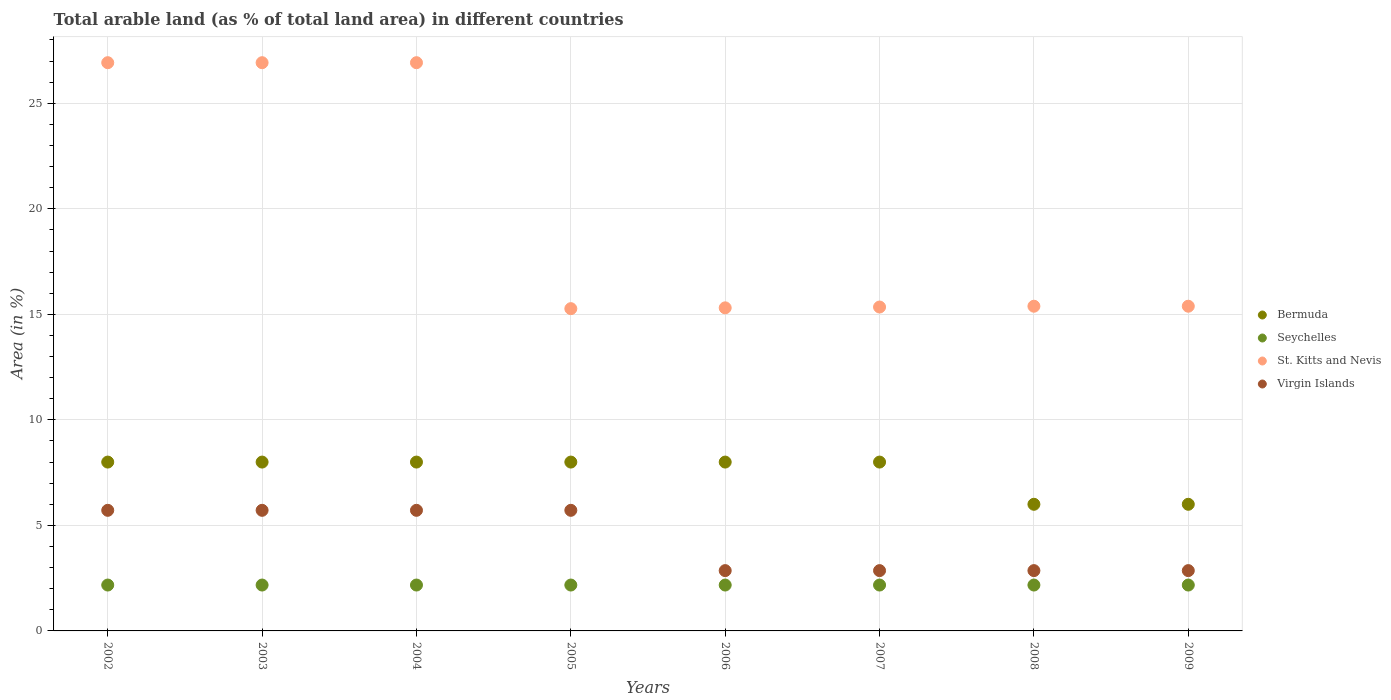How many different coloured dotlines are there?
Your answer should be compact. 4. What is the percentage of arable land in Virgin Islands in 2009?
Your response must be concise. 2.86. Across all years, what is the maximum percentage of arable land in Virgin Islands?
Ensure brevity in your answer.  5.71. Across all years, what is the minimum percentage of arable land in Bermuda?
Offer a terse response. 6. In which year was the percentage of arable land in Virgin Islands minimum?
Offer a terse response. 2006. What is the total percentage of arable land in St. Kitts and Nevis in the graph?
Make the answer very short. 157.46. What is the difference between the percentage of arable land in St. Kitts and Nevis in 2006 and that in 2008?
Make the answer very short. -0.08. What is the difference between the percentage of arable land in Virgin Islands in 2002 and the percentage of arable land in Seychelles in 2009?
Offer a terse response. 3.54. What is the average percentage of arable land in Seychelles per year?
Make the answer very short. 2.17. In the year 2009, what is the difference between the percentage of arable land in Virgin Islands and percentage of arable land in St. Kitts and Nevis?
Ensure brevity in your answer.  -12.53. In how many years, is the percentage of arable land in St. Kitts and Nevis greater than 27 %?
Provide a succinct answer. 0. Is the percentage of arable land in Virgin Islands in 2003 less than that in 2007?
Provide a succinct answer. No. Is the difference between the percentage of arable land in Virgin Islands in 2004 and 2006 greater than the difference between the percentage of arable land in St. Kitts and Nevis in 2004 and 2006?
Your response must be concise. No. What is the difference between the highest and the second highest percentage of arable land in Virgin Islands?
Provide a short and direct response. 0. What is the difference between the highest and the lowest percentage of arable land in St. Kitts and Nevis?
Provide a short and direct response. 11.65. Is it the case that in every year, the sum of the percentage of arable land in Virgin Islands and percentage of arable land in St. Kitts and Nevis  is greater than the percentage of arable land in Bermuda?
Provide a succinct answer. Yes. Is the percentage of arable land in Virgin Islands strictly greater than the percentage of arable land in Bermuda over the years?
Offer a very short reply. No. Is the percentage of arable land in Seychelles strictly less than the percentage of arable land in St. Kitts and Nevis over the years?
Give a very brief answer. Yes. How many dotlines are there?
Your response must be concise. 4. What is the difference between two consecutive major ticks on the Y-axis?
Keep it short and to the point. 5. Are the values on the major ticks of Y-axis written in scientific E-notation?
Offer a terse response. No. Does the graph contain any zero values?
Make the answer very short. No. Does the graph contain grids?
Your response must be concise. Yes. How many legend labels are there?
Your answer should be compact. 4. What is the title of the graph?
Your answer should be compact. Total arable land (as % of total land area) in different countries. Does "Switzerland" appear as one of the legend labels in the graph?
Your answer should be very brief. No. What is the label or title of the X-axis?
Offer a very short reply. Years. What is the label or title of the Y-axis?
Provide a succinct answer. Area (in %). What is the Area (in %) in Seychelles in 2002?
Provide a succinct answer. 2.17. What is the Area (in %) of St. Kitts and Nevis in 2002?
Offer a very short reply. 26.92. What is the Area (in %) of Virgin Islands in 2002?
Keep it short and to the point. 5.71. What is the Area (in %) of Bermuda in 2003?
Provide a succinct answer. 8. What is the Area (in %) in Seychelles in 2003?
Your answer should be very brief. 2.17. What is the Area (in %) in St. Kitts and Nevis in 2003?
Your response must be concise. 26.92. What is the Area (in %) in Virgin Islands in 2003?
Give a very brief answer. 5.71. What is the Area (in %) in Bermuda in 2004?
Offer a terse response. 8. What is the Area (in %) of Seychelles in 2004?
Give a very brief answer. 2.17. What is the Area (in %) in St. Kitts and Nevis in 2004?
Your answer should be very brief. 26.92. What is the Area (in %) of Virgin Islands in 2004?
Your answer should be very brief. 5.71. What is the Area (in %) of Seychelles in 2005?
Your answer should be very brief. 2.17. What is the Area (in %) of St. Kitts and Nevis in 2005?
Your response must be concise. 15.27. What is the Area (in %) of Virgin Islands in 2005?
Ensure brevity in your answer.  5.71. What is the Area (in %) in Bermuda in 2006?
Your answer should be compact. 8. What is the Area (in %) of Seychelles in 2006?
Offer a terse response. 2.17. What is the Area (in %) in St. Kitts and Nevis in 2006?
Your answer should be very brief. 15.31. What is the Area (in %) of Virgin Islands in 2006?
Provide a short and direct response. 2.86. What is the Area (in %) in Bermuda in 2007?
Provide a succinct answer. 8. What is the Area (in %) of Seychelles in 2007?
Your answer should be very brief. 2.17. What is the Area (in %) in St. Kitts and Nevis in 2007?
Offer a terse response. 15.35. What is the Area (in %) in Virgin Islands in 2007?
Keep it short and to the point. 2.86. What is the Area (in %) in Bermuda in 2008?
Your response must be concise. 6. What is the Area (in %) of Seychelles in 2008?
Your answer should be very brief. 2.17. What is the Area (in %) of St. Kitts and Nevis in 2008?
Your answer should be compact. 15.38. What is the Area (in %) in Virgin Islands in 2008?
Your answer should be very brief. 2.86. What is the Area (in %) in Seychelles in 2009?
Offer a terse response. 2.17. What is the Area (in %) of St. Kitts and Nevis in 2009?
Keep it short and to the point. 15.38. What is the Area (in %) of Virgin Islands in 2009?
Provide a short and direct response. 2.86. Across all years, what is the maximum Area (in %) in Seychelles?
Your answer should be compact. 2.17. Across all years, what is the maximum Area (in %) in St. Kitts and Nevis?
Your answer should be very brief. 26.92. Across all years, what is the maximum Area (in %) in Virgin Islands?
Make the answer very short. 5.71. Across all years, what is the minimum Area (in %) of Seychelles?
Give a very brief answer. 2.17. Across all years, what is the minimum Area (in %) of St. Kitts and Nevis?
Provide a short and direct response. 15.27. Across all years, what is the minimum Area (in %) of Virgin Islands?
Ensure brevity in your answer.  2.86. What is the total Area (in %) in Seychelles in the graph?
Keep it short and to the point. 17.39. What is the total Area (in %) of St. Kitts and Nevis in the graph?
Make the answer very short. 157.46. What is the total Area (in %) in Virgin Islands in the graph?
Give a very brief answer. 34.29. What is the difference between the Area (in %) of St. Kitts and Nevis in 2002 and that in 2003?
Keep it short and to the point. 0. What is the difference between the Area (in %) of Virgin Islands in 2002 and that in 2003?
Offer a very short reply. 0. What is the difference between the Area (in %) of Seychelles in 2002 and that in 2004?
Offer a very short reply. 0. What is the difference between the Area (in %) in St. Kitts and Nevis in 2002 and that in 2004?
Offer a very short reply. 0. What is the difference between the Area (in %) in Virgin Islands in 2002 and that in 2004?
Provide a succinct answer. 0. What is the difference between the Area (in %) in Bermuda in 2002 and that in 2005?
Make the answer very short. 0. What is the difference between the Area (in %) in Seychelles in 2002 and that in 2005?
Ensure brevity in your answer.  0. What is the difference between the Area (in %) of St. Kitts and Nevis in 2002 and that in 2005?
Offer a very short reply. 11.65. What is the difference between the Area (in %) in Seychelles in 2002 and that in 2006?
Your response must be concise. 0. What is the difference between the Area (in %) in St. Kitts and Nevis in 2002 and that in 2006?
Give a very brief answer. 11.62. What is the difference between the Area (in %) of Virgin Islands in 2002 and that in 2006?
Provide a short and direct response. 2.86. What is the difference between the Area (in %) of Bermuda in 2002 and that in 2007?
Your answer should be compact. 0. What is the difference between the Area (in %) of Seychelles in 2002 and that in 2007?
Provide a succinct answer. 0. What is the difference between the Area (in %) of St. Kitts and Nevis in 2002 and that in 2007?
Make the answer very short. 11.58. What is the difference between the Area (in %) of Virgin Islands in 2002 and that in 2007?
Ensure brevity in your answer.  2.86. What is the difference between the Area (in %) in Bermuda in 2002 and that in 2008?
Make the answer very short. 2. What is the difference between the Area (in %) of Seychelles in 2002 and that in 2008?
Make the answer very short. 0. What is the difference between the Area (in %) in St. Kitts and Nevis in 2002 and that in 2008?
Your response must be concise. 11.54. What is the difference between the Area (in %) of Virgin Islands in 2002 and that in 2008?
Provide a succinct answer. 2.86. What is the difference between the Area (in %) of Seychelles in 2002 and that in 2009?
Keep it short and to the point. 0. What is the difference between the Area (in %) of St. Kitts and Nevis in 2002 and that in 2009?
Offer a very short reply. 11.54. What is the difference between the Area (in %) in Virgin Islands in 2002 and that in 2009?
Provide a short and direct response. 2.86. What is the difference between the Area (in %) of Bermuda in 2003 and that in 2004?
Offer a very short reply. 0. What is the difference between the Area (in %) in Seychelles in 2003 and that in 2004?
Keep it short and to the point. 0. What is the difference between the Area (in %) of Bermuda in 2003 and that in 2005?
Offer a very short reply. 0. What is the difference between the Area (in %) of St. Kitts and Nevis in 2003 and that in 2005?
Keep it short and to the point. 11.65. What is the difference between the Area (in %) of Virgin Islands in 2003 and that in 2005?
Provide a short and direct response. 0. What is the difference between the Area (in %) of Bermuda in 2003 and that in 2006?
Offer a terse response. 0. What is the difference between the Area (in %) of Seychelles in 2003 and that in 2006?
Offer a terse response. 0. What is the difference between the Area (in %) in St. Kitts and Nevis in 2003 and that in 2006?
Your answer should be compact. 11.62. What is the difference between the Area (in %) of Virgin Islands in 2003 and that in 2006?
Offer a terse response. 2.86. What is the difference between the Area (in %) in Bermuda in 2003 and that in 2007?
Provide a short and direct response. 0. What is the difference between the Area (in %) in Seychelles in 2003 and that in 2007?
Offer a terse response. 0. What is the difference between the Area (in %) in St. Kitts and Nevis in 2003 and that in 2007?
Offer a very short reply. 11.58. What is the difference between the Area (in %) in Virgin Islands in 2003 and that in 2007?
Your answer should be very brief. 2.86. What is the difference between the Area (in %) in St. Kitts and Nevis in 2003 and that in 2008?
Provide a succinct answer. 11.54. What is the difference between the Area (in %) of Virgin Islands in 2003 and that in 2008?
Make the answer very short. 2.86. What is the difference between the Area (in %) of Seychelles in 2003 and that in 2009?
Make the answer very short. 0. What is the difference between the Area (in %) of St. Kitts and Nevis in 2003 and that in 2009?
Your answer should be compact. 11.54. What is the difference between the Area (in %) of Virgin Islands in 2003 and that in 2009?
Provide a succinct answer. 2.86. What is the difference between the Area (in %) of St. Kitts and Nevis in 2004 and that in 2005?
Keep it short and to the point. 11.65. What is the difference between the Area (in %) of Virgin Islands in 2004 and that in 2005?
Your answer should be very brief. 0. What is the difference between the Area (in %) in St. Kitts and Nevis in 2004 and that in 2006?
Your answer should be compact. 11.62. What is the difference between the Area (in %) of Virgin Islands in 2004 and that in 2006?
Ensure brevity in your answer.  2.86. What is the difference between the Area (in %) in Bermuda in 2004 and that in 2007?
Your answer should be compact. 0. What is the difference between the Area (in %) of Seychelles in 2004 and that in 2007?
Your response must be concise. 0. What is the difference between the Area (in %) of St. Kitts and Nevis in 2004 and that in 2007?
Provide a succinct answer. 11.58. What is the difference between the Area (in %) in Virgin Islands in 2004 and that in 2007?
Provide a short and direct response. 2.86. What is the difference between the Area (in %) of St. Kitts and Nevis in 2004 and that in 2008?
Offer a very short reply. 11.54. What is the difference between the Area (in %) in Virgin Islands in 2004 and that in 2008?
Offer a very short reply. 2.86. What is the difference between the Area (in %) of Seychelles in 2004 and that in 2009?
Your answer should be very brief. 0. What is the difference between the Area (in %) of St. Kitts and Nevis in 2004 and that in 2009?
Your answer should be compact. 11.54. What is the difference between the Area (in %) of Virgin Islands in 2004 and that in 2009?
Keep it short and to the point. 2.86. What is the difference between the Area (in %) of Seychelles in 2005 and that in 2006?
Make the answer very short. 0. What is the difference between the Area (in %) in St. Kitts and Nevis in 2005 and that in 2006?
Keep it short and to the point. -0.04. What is the difference between the Area (in %) in Virgin Islands in 2005 and that in 2006?
Keep it short and to the point. 2.86. What is the difference between the Area (in %) in Seychelles in 2005 and that in 2007?
Keep it short and to the point. 0. What is the difference between the Area (in %) in St. Kitts and Nevis in 2005 and that in 2007?
Provide a short and direct response. -0.08. What is the difference between the Area (in %) in Virgin Islands in 2005 and that in 2007?
Ensure brevity in your answer.  2.86. What is the difference between the Area (in %) in Bermuda in 2005 and that in 2008?
Your response must be concise. 2. What is the difference between the Area (in %) of St. Kitts and Nevis in 2005 and that in 2008?
Provide a succinct answer. -0.12. What is the difference between the Area (in %) of Virgin Islands in 2005 and that in 2008?
Offer a very short reply. 2.86. What is the difference between the Area (in %) in Seychelles in 2005 and that in 2009?
Ensure brevity in your answer.  0. What is the difference between the Area (in %) in St. Kitts and Nevis in 2005 and that in 2009?
Ensure brevity in your answer.  -0.12. What is the difference between the Area (in %) of Virgin Islands in 2005 and that in 2009?
Your answer should be very brief. 2.86. What is the difference between the Area (in %) in Seychelles in 2006 and that in 2007?
Offer a terse response. 0. What is the difference between the Area (in %) in St. Kitts and Nevis in 2006 and that in 2007?
Provide a succinct answer. -0.04. What is the difference between the Area (in %) of Virgin Islands in 2006 and that in 2007?
Your response must be concise. 0. What is the difference between the Area (in %) of Seychelles in 2006 and that in 2008?
Provide a succinct answer. 0. What is the difference between the Area (in %) in St. Kitts and Nevis in 2006 and that in 2008?
Provide a succinct answer. -0.08. What is the difference between the Area (in %) in Virgin Islands in 2006 and that in 2008?
Keep it short and to the point. 0. What is the difference between the Area (in %) in Seychelles in 2006 and that in 2009?
Provide a succinct answer. 0. What is the difference between the Area (in %) in St. Kitts and Nevis in 2006 and that in 2009?
Give a very brief answer. -0.08. What is the difference between the Area (in %) of Virgin Islands in 2006 and that in 2009?
Offer a very short reply. 0. What is the difference between the Area (in %) in Seychelles in 2007 and that in 2008?
Keep it short and to the point. 0. What is the difference between the Area (in %) of St. Kitts and Nevis in 2007 and that in 2008?
Ensure brevity in your answer.  -0.04. What is the difference between the Area (in %) of St. Kitts and Nevis in 2007 and that in 2009?
Provide a succinct answer. -0.04. What is the difference between the Area (in %) in Bermuda in 2008 and that in 2009?
Ensure brevity in your answer.  0. What is the difference between the Area (in %) of Seychelles in 2008 and that in 2009?
Offer a very short reply. 0. What is the difference between the Area (in %) of Bermuda in 2002 and the Area (in %) of Seychelles in 2003?
Offer a terse response. 5.83. What is the difference between the Area (in %) in Bermuda in 2002 and the Area (in %) in St. Kitts and Nevis in 2003?
Your answer should be very brief. -18.92. What is the difference between the Area (in %) of Bermuda in 2002 and the Area (in %) of Virgin Islands in 2003?
Provide a short and direct response. 2.29. What is the difference between the Area (in %) of Seychelles in 2002 and the Area (in %) of St. Kitts and Nevis in 2003?
Make the answer very short. -24.75. What is the difference between the Area (in %) of Seychelles in 2002 and the Area (in %) of Virgin Islands in 2003?
Make the answer very short. -3.54. What is the difference between the Area (in %) of St. Kitts and Nevis in 2002 and the Area (in %) of Virgin Islands in 2003?
Provide a succinct answer. 21.21. What is the difference between the Area (in %) in Bermuda in 2002 and the Area (in %) in Seychelles in 2004?
Keep it short and to the point. 5.83. What is the difference between the Area (in %) of Bermuda in 2002 and the Area (in %) of St. Kitts and Nevis in 2004?
Keep it short and to the point. -18.92. What is the difference between the Area (in %) of Bermuda in 2002 and the Area (in %) of Virgin Islands in 2004?
Keep it short and to the point. 2.29. What is the difference between the Area (in %) in Seychelles in 2002 and the Area (in %) in St. Kitts and Nevis in 2004?
Give a very brief answer. -24.75. What is the difference between the Area (in %) of Seychelles in 2002 and the Area (in %) of Virgin Islands in 2004?
Keep it short and to the point. -3.54. What is the difference between the Area (in %) in St. Kitts and Nevis in 2002 and the Area (in %) in Virgin Islands in 2004?
Ensure brevity in your answer.  21.21. What is the difference between the Area (in %) in Bermuda in 2002 and the Area (in %) in Seychelles in 2005?
Your answer should be compact. 5.83. What is the difference between the Area (in %) of Bermuda in 2002 and the Area (in %) of St. Kitts and Nevis in 2005?
Offer a very short reply. -7.27. What is the difference between the Area (in %) in Bermuda in 2002 and the Area (in %) in Virgin Islands in 2005?
Give a very brief answer. 2.29. What is the difference between the Area (in %) of Seychelles in 2002 and the Area (in %) of St. Kitts and Nevis in 2005?
Your answer should be compact. -13.1. What is the difference between the Area (in %) of Seychelles in 2002 and the Area (in %) of Virgin Islands in 2005?
Provide a short and direct response. -3.54. What is the difference between the Area (in %) of St. Kitts and Nevis in 2002 and the Area (in %) of Virgin Islands in 2005?
Provide a succinct answer. 21.21. What is the difference between the Area (in %) of Bermuda in 2002 and the Area (in %) of Seychelles in 2006?
Ensure brevity in your answer.  5.83. What is the difference between the Area (in %) in Bermuda in 2002 and the Area (in %) in St. Kitts and Nevis in 2006?
Your response must be concise. -7.31. What is the difference between the Area (in %) in Bermuda in 2002 and the Area (in %) in Virgin Islands in 2006?
Your response must be concise. 5.14. What is the difference between the Area (in %) in Seychelles in 2002 and the Area (in %) in St. Kitts and Nevis in 2006?
Provide a succinct answer. -13.13. What is the difference between the Area (in %) in Seychelles in 2002 and the Area (in %) in Virgin Islands in 2006?
Provide a succinct answer. -0.68. What is the difference between the Area (in %) of St. Kitts and Nevis in 2002 and the Area (in %) of Virgin Islands in 2006?
Provide a succinct answer. 24.07. What is the difference between the Area (in %) in Bermuda in 2002 and the Area (in %) in Seychelles in 2007?
Your answer should be very brief. 5.83. What is the difference between the Area (in %) in Bermuda in 2002 and the Area (in %) in St. Kitts and Nevis in 2007?
Provide a short and direct response. -7.35. What is the difference between the Area (in %) in Bermuda in 2002 and the Area (in %) in Virgin Islands in 2007?
Offer a terse response. 5.14. What is the difference between the Area (in %) of Seychelles in 2002 and the Area (in %) of St. Kitts and Nevis in 2007?
Your answer should be very brief. -13.17. What is the difference between the Area (in %) of Seychelles in 2002 and the Area (in %) of Virgin Islands in 2007?
Provide a short and direct response. -0.68. What is the difference between the Area (in %) of St. Kitts and Nevis in 2002 and the Area (in %) of Virgin Islands in 2007?
Make the answer very short. 24.07. What is the difference between the Area (in %) of Bermuda in 2002 and the Area (in %) of Seychelles in 2008?
Provide a short and direct response. 5.83. What is the difference between the Area (in %) in Bermuda in 2002 and the Area (in %) in St. Kitts and Nevis in 2008?
Keep it short and to the point. -7.38. What is the difference between the Area (in %) of Bermuda in 2002 and the Area (in %) of Virgin Islands in 2008?
Provide a succinct answer. 5.14. What is the difference between the Area (in %) in Seychelles in 2002 and the Area (in %) in St. Kitts and Nevis in 2008?
Your response must be concise. -13.21. What is the difference between the Area (in %) in Seychelles in 2002 and the Area (in %) in Virgin Islands in 2008?
Provide a short and direct response. -0.68. What is the difference between the Area (in %) of St. Kitts and Nevis in 2002 and the Area (in %) of Virgin Islands in 2008?
Make the answer very short. 24.07. What is the difference between the Area (in %) in Bermuda in 2002 and the Area (in %) in Seychelles in 2009?
Make the answer very short. 5.83. What is the difference between the Area (in %) of Bermuda in 2002 and the Area (in %) of St. Kitts and Nevis in 2009?
Make the answer very short. -7.38. What is the difference between the Area (in %) of Bermuda in 2002 and the Area (in %) of Virgin Islands in 2009?
Ensure brevity in your answer.  5.14. What is the difference between the Area (in %) of Seychelles in 2002 and the Area (in %) of St. Kitts and Nevis in 2009?
Keep it short and to the point. -13.21. What is the difference between the Area (in %) in Seychelles in 2002 and the Area (in %) in Virgin Islands in 2009?
Your answer should be very brief. -0.68. What is the difference between the Area (in %) of St. Kitts and Nevis in 2002 and the Area (in %) of Virgin Islands in 2009?
Keep it short and to the point. 24.07. What is the difference between the Area (in %) in Bermuda in 2003 and the Area (in %) in Seychelles in 2004?
Keep it short and to the point. 5.83. What is the difference between the Area (in %) of Bermuda in 2003 and the Area (in %) of St. Kitts and Nevis in 2004?
Your response must be concise. -18.92. What is the difference between the Area (in %) in Bermuda in 2003 and the Area (in %) in Virgin Islands in 2004?
Give a very brief answer. 2.29. What is the difference between the Area (in %) in Seychelles in 2003 and the Area (in %) in St. Kitts and Nevis in 2004?
Provide a succinct answer. -24.75. What is the difference between the Area (in %) in Seychelles in 2003 and the Area (in %) in Virgin Islands in 2004?
Give a very brief answer. -3.54. What is the difference between the Area (in %) in St. Kitts and Nevis in 2003 and the Area (in %) in Virgin Islands in 2004?
Provide a short and direct response. 21.21. What is the difference between the Area (in %) of Bermuda in 2003 and the Area (in %) of Seychelles in 2005?
Provide a short and direct response. 5.83. What is the difference between the Area (in %) in Bermuda in 2003 and the Area (in %) in St. Kitts and Nevis in 2005?
Ensure brevity in your answer.  -7.27. What is the difference between the Area (in %) in Bermuda in 2003 and the Area (in %) in Virgin Islands in 2005?
Keep it short and to the point. 2.29. What is the difference between the Area (in %) in Seychelles in 2003 and the Area (in %) in St. Kitts and Nevis in 2005?
Keep it short and to the point. -13.1. What is the difference between the Area (in %) of Seychelles in 2003 and the Area (in %) of Virgin Islands in 2005?
Keep it short and to the point. -3.54. What is the difference between the Area (in %) in St. Kitts and Nevis in 2003 and the Area (in %) in Virgin Islands in 2005?
Offer a very short reply. 21.21. What is the difference between the Area (in %) of Bermuda in 2003 and the Area (in %) of Seychelles in 2006?
Your answer should be very brief. 5.83. What is the difference between the Area (in %) in Bermuda in 2003 and the Area (in %) in St. Kitts and Nevis in 2006?
Provide a short and direct response. -7.31. What is the difference between the Area (in %) in Bermuda in 2003 and the Area (in %) in Virgin Islands in 2006?
Ensure brevity in your answer.  5.14. What is the difference between the Area (in %) of Seychelles in 2003 and the Area (in %) of St. Kitts and Nevis in 2006?
Give a very brief answer. -13.13. What is the difference between the Area (in %) in Seychelles in 2003 and the Area (in %) in Virgin Islands in 2006?
Provide a succinct answer. -0.68. What is the difference between the Area (in %) in St. Kitts and Nevis in 2003 and the Area (in %) in Virgin Islands in 2006?
Offer a very short reply. 24.07. What is the difference between the Area (in %) in Bermuda in 2003 and the Area (in %) in Seychelles in 2007?
Your answer should be very brief. 5.83. What is the difference between the Area (in %) of Bermuda in 2003 and the Area (in %) of St. Kitts and Nevis in 2007?
Offer a terse response. -7.35. What is the difference between the Area (in %) in Bermuda in 2003 and the Area (in %) in Virgin Islands in 2007?
Give a very brief answer. 5.14. What is the difference between the Area (in %) in Seychelles in 2003 and the Area (in %) in St. Kitts and Nevis in 2007?
Offer a very short reply. -13.17. What is the difference between the Area (in %) of Seychelles in 2003 and the Area (in %) of Virgin Islands in 2007?
Provide a short and direct response. -0.68. What is the difference between the Area (in %) of St. Kitts and Nevis in 2003 and the Area (in %) of Virgin Islands in 2007?
Offer a very short reply. 24.07. What is the difference between the Area (in %) in Bermuda in 2003 and the Area (in %) in Seychelles in 2008?
Your answer should be very brief. 5.83. What is the difference between the Area (in %) in Bermuda in 2003 and the Area (in %) in St. Kitts and Nevis in 2008?
Make the answer very short. -7.38. What is the difference between the Area (in %) in Bermuda in 2003 and the Area (in %) in Virgin Islands in 2008?
Keep it short and to the point. 5.14. What is the difference between the Area (in %) of Seychelles in 2003 and the Area (in %) of St. Kitts and Nevis in 2008?
Make the answer very short. -13.21. What is the difference between the Area (in %) in Seychelles in 2003 and the Area (in %) in Virgin Islands in 2008?
Provide a short and direct response. -0.68. What is the difference between the Area (in %) in St. Kitts and Nevis in 2003 and the Area (in %) in Virgin Islands in 2008?
Provide a short and direct response. 24.07. What is the difference between the Area (in %) of Bermuda in 2003 and the Area (in %) of Seychelles in 2009?
Provide a succinct answer. 5.83. What is the difference between the Area (in %) in Bermuda in 2003 and the Area (in %) in St. Kitts and Nevis in 2009?
Provide a short and direct response. -7.38. What is the difference between the Area (in %) of Bermuda in 2003 and the Area (in %) of Virgin Islands in 2009?
Provide a succinct answer. 5.14. What is the difference between the Area (in %) in Seychelles in 2003 and the Area (in %) in St. Kitts and Nevis in 2009?
Keep it short and to the point. -13.21. What is the difference between the Area (in %) of Seychelles in 2003 and the Area (in %) of Virgin Islands in 2009?
Provide a short and direct response. -0.68. What is the difference between the Area (in %) in St. Kitts and Nevis in 2003 and the Area (in %) in Virgin Islands in 2009?
Make the answer very short. 24.07. What is the difference between the Area (in %) in Bermuda in 2004 and the Area (in %) in Seychelles in 2005?
Your response must be concise. 5.83. What is the difference between the Area (in %) in Bermuda in 2004 and the Area (in %) in St. Kitts and Nevis in 2005?
Give a very brief answer. -7.27. What is the difference between the Area (in %) in Bermuda in 2004 and the Area (in %) in Virgin Islands in 2005?
Offer a terse response. 2.29. What is the difference between the Area (in %) in Seychelles in 2004 and the Area (in %) in St. Kitts and Nevis in 2005?
Make the answer very short. -13.1. What is the difference between the Area (in %) in Seychelles in 2004 and the Area (in %) in Virgin Islands in 2005?
Your answer should be very brief. -3.54. What is the difference between the Area (in %) in St. Kitts and Nevis in 2004 and the Area (in %) in Virgin Islands in 2005?
Provide a short and direct response. 21.21. What is the difference between the Area (in %) of Bermuda in 2004 and the Area (in %) of Seychelles in 2006?
Offer a very short reply. 5.83. What is the difference between the Area (in %) in Bermuda in 2004 and the Area (in %) in St. Kitts and Nevis in 2006?
Give a very brief answer. -7.31. What is the difference between the Area (in %) of Bermuda in 2004 and the Area (in %) of Virgin Islands in 2006?
Your response must be concise. 5.14. What is the difference between the Area (in %) of Seychelles in 2004 and the Area (in %) of St. Kitts and Nevis in 2006?
Provide a succinct answer. -13.13. What is the difference between the Area (in %) in Seychelles in 2004 and the Area (in %) in Virgin Islands in 2006?
Offer a very short reply. -0.68. What is the difference between the Area (in %) in St. Kitts and Nevis in 2004 and the Area (in %) in Virgin Islands in 2006?
Your response must be concise. 24.07. What is the difference between the Area (in %) in Bermuda in 2004 and the Area (in %) in Seychelles in 2007?
Provide a short and direct response. 5.83. What is the difference between the Area (in %) of Bermuda in 2004 and the Area (in %) of St. Kitts and Nevis in 2007?
Your answer should be very brief. -7.35. What is the difference between the Area (in %) in Bermuda in 2004 and the Area (in %) in Virgin Islands in 2007?
Your answer should be very brief. 5.14. What is the difference between the Area (in %) of Seychelles in 2004 and the Area (in %) of St. Kitts and Nevis in 2007?
Offer a very short reply. -13.17. What is the difference between the Area (in %) in Seychelles in 2004 and the Area (in %) in Virgin Islands in 2007?
Make the answer very short. -0.68. What is the difference between the Area (in %) of St. Kitts and Nevis in 2004 and the Area (in %) of Virgin Islands in 2007?
Provide a short and direct response. 24.07. What is the difference between the Area (in %) in Bermuda in 2004 and the Area (in %) in Seychelles in 2008?
Make the answer very short. 5.83. What is the difference between the Area (in %) in Bermuda in 2004 and the Area (in %) in St. Kitts and Nevis in 2008?
Provide a short and direct response. -7.38. What is the difference between the Area (in %) of Bermuda in 2004 and the Area (in %) of Virgin Islands in 2008?
Give a very brief answer. 5.14. What is the difference between the Area (in %) of Seychelles in 2004 and the Area (in %) of St. Kitts and Nevis in 2008?
Offer a very short reply. -13.21. What is the difference between the Area (in %) in Seychelles in 2004 and the Area (in %) in Virgin Islands in 2008?
Keep it short and to the point. -0.68. What is the difference between the Area (in %) of St. Kitts and Nevis in 2004 and the Area (in %) of Virgin Islands in 2008?
Provide a succinct answer. 24.07. What is the difference between the Area (in %) of Bermuda in 2004 and the Area (in %) of Seychelles in 2009?
Provide a short and direct response. 5.83. What is the difference between the Area (in %) of Bermuda in 2004 and the Area (in %) of St. Kitts and Nevis in 2009?
Your response must be concise. -7.38. What is the difference between the Area (in %) in Bermuda in 2004 and the Area (in %) in Virgin Islands in 2009?
Your answer should be compact. 5.14. What is the difference between the Area (in %) of Seychelles in 2004 and the Area (in %) of St. Kitts and Nevis in 2009?
Give a very brief answer. -13.21. What is the difference between the Area (in %) in Seychelles in 2004 and the Area (in %) in Virgin Islands in 2009?
Your response must be concise. -0.68. What is the difference between the Area (in %) in St. Kitts and Nevis in 2004 and the Area (in %) in Virgin Islands in 2009?
Offer a terse response. 24.07. What is the difference between the Area (in %) of Bermuda in 2005 and the Area (in %) of Seychelles in 2006?
Your answer should be very brief. 5.83. What is the difference between the Area (in %) of Bermuda in 2005 and the Area (in %) of St. Kitts and Nevis in 2006?
Your response must be concise. -7.31. What is the difference between the Area (in %) in Bermuda in 2005 and the Area (in %) in Virgin Islands in 2006?
Make the answer very short. 5.14. What is the difference between the Area (in %) in Seychelles in 2005 and the Area (in %) in St. Kitts and Nevis in 2006?
Offer a terse response. -13.13. What is the difference between the Area (in %) of Seychelles in 2005 and the Area (in %) of Virgin Islands in 2006?
Your answer should be compact. -0.68. What is the difference between the Area (in %) in St. Kitts and Nevis in 2005 and the Area (in %) in Virgin Islands in 2006?
Ensure brevity in your answer.  12.41. What is the difference between the Area (in %) in Bermuda in 2005 and the Area (in %) in Seychelles in 2007?
Offer a very short reply. 5.83. What is the difference between the Area (in %) in Bermuda in 2005 and the Area (in %) in St. Kitts and Nevis in 2007?
Provide a succinct answer. -7.35. What is the difference between the Area (in %) in Bermuda in 2005 and the Area (in %) in Virgin Islands in 2007?
Provide a short and direct response. 5.14. What is the difference between the Area (in %) in Seychelles in 2005 and the Area (in %) in St. Kitts and Nevis in 2007?
Ensure brevity in your answer.  -13.17. What is the difference between the Area (in %) of Seychelles in 2005 and the Area (in %) of Virgin Islands in 2007?
Offer a very short reply. -0.68. What is the difference between the Area (in %) in St. Kitts and Nevis in 2005 and the Area (in %) in Virgin Islands in 2007?
Ensure brevity in your answer.  12.41. What is the difference between the Area (in %) of Bermuda in 2005 and the Area (in %) of Seychelles in 2008?
Provide a succinct answer. 5.83. What is the difference between the Area (in %) in Bermuda in 2005 and the Area (in %) in St. Kitts and Nevis in 2008?
Ensure brevity in your answer.  -7.38. What is the difference between the Area (in %) of Bermuda in 2005 and the Area (in %) of Virgin Islands in 2008?
Your answer should be very brief. 5.14. What is the difference between the Area (in %) in Seychelles in 2005 and the Area (in %) in St. Kitts and Nevis in 2008?
Provide a short and direct response. -13.21. What is the difference between the Area (in %) of Seychelles in 2005 and the Area (in %) of Virgin Islands in 2008?
Offer a terse response. -0.68. What is the difference between the Area (in %) in St. Kitts and Nevis in 2005 and the Area (in %) in Virgin Islands in 2008?
Make the answer very short. 12.41. What is the difference between the Area (in %) of Bermuda in 2005 and the Area (in %) of Seychelles in 2009?
Offer a very short reply. 5.83. What is the difference between the Area (in %) of Bermuda in 2005 and the Area (in %) of St. Kitts and Nevis in 2009?
Ensure brevity in your answer.  -7.38. What is the difference between the Area (in %) of Bermuda in 2005 and the Area (in %) of Virgin Islands in 2009?
Provide a succinct answer. 5.14. What is the difference between the Area (in %) in Seychelles in 2005 and the Area (in %) in St. Kitts and Nevis in 2009?
Your answer should be very brief. -13.21. What is the difference between the Area (in %) in Seychelles in 2005 and the Area (in %) in Virgin Islands in 2009?
Your answer should be very brief. -0.68. What is the difference between the Area (in %) in St. Kitts and Nevis in 2005 and the Area (in %) in Virgin Islands in 2009?
Your answer should be compact. 12.41. What is the difference between the Area (in %) of Bermuda in 2006 and the Area (in %) of Seychelles in 2007?
Provide a succinct answer. 5.83. What is the difference between the Area (in %) of Bermuda in 2006 and the Area (in %) of St. Kitts and Nevis in 2007?
Your answer should be compact. -7.35. What is the difference between the Area (in %) of Bermuda in 2006 and the Area (in %) of Virgin Islands in 2007?
Make the answer very short. 5.14. What is the difference between the Area (in %) in Seychelles in 2006 and the Area (in %) in St. Kitts and Nevis in 2007?
Ensure brevity in your answer.  -13.17. What is the difference between the Area (in %) of Seychelles in 2006 and the Area (in %) of Virgin Islands in 2007?
Give a very brief answer. -0.68. What is the difference between the Area (in %) in St. Kitts and Nevis in 2006 and the Area (in %) in Virgin Islands in 2007?
Give a very brief answer. 12.45. What is the difference between the Area (in %) in Bermuda in 2006 and the Area (in %) in Seychelles in 2008?
Offer a very short reply. 5.83. What is the difference between the Area (in %) in Bermuda in 2006 and the Area (in %) in St. Kitts and Nevis in 2008?
Keep it short and to the point. -7.38. What is the difference between the Area (in %) of Bermuda in 2006 and the Area (in %) of Virgin Islands in 2008?
Make the answer very short. 5.14. What is the difference between the Area (in %) of Seychelles in 2006 and the Area (in %) of St. Kitts and Nevis in 2008?
Your answer should be very brief. -13.21. What is the difference between the Area (in %) of Seychelles in 2006 and the Area (in %) of Virgin Islands in 2008?
Your answer should be compact. -0.68. What is the difference between the Area (in %) in St. Kitts and Nevis in 2006 and the Area (in %) in Virgin Islands in 2008?
Your answer should be compact. 12.45. What is the difference between the Area (in %) of Bermuda in 2006 and the Area (in %) of Seychelles in 2009?
Offer a very short reply. 5.83. What is the difference between the Area (in %) in Bermuda in 2006 and the Area (in %) in St. Kitts and Nevis in 2009?
Your answer should be compact. -7.38. What is the difference between the Area (in %) of Bermuda in 2006 and the Area (in %) of Virgin Islands in 2009?
Your answer should be very brief. 5.14. What is the difference between the Area (in %) in Seychelles in 2006 and the Area (in %) in St. Kitts and Nevis in 2009?
Provide a short and direct response. -13.21. What is the difference between the Area (in %) of Seychelles in 2006 and the Area (in %) of Virgin Islands in 2009?
Make the answer very short. -0.68. What is the difference between the Area (in %) of St. Kitts and Nevis in 2006 and the Area (in %) of Virgin Islands in 2009?
Give a very brief answer. 12.45. What is the difference between the Area (in %) in Bermuda in 2007 and the Area (in %) in Seychelles in 2008?
Make the answer very short. 5.83. What is the difference between the Area (in %) in Bermuda in 2007 and the Area (in %) in St. Kitts and Nevis in 2008?
Make the answer very short. -7.38. What is the difference between the Area (in %) of Bermuda in 2007 and the Area (in %) of Virgin Islands in 2008?
Give a very brief answer. 5.14. What is the difference between the Area (in %) of Seychelles in 2007 and the Area (in %) of St. Kitts and Nevis in 2008?
Your response must be concise. -13.21. What is the difference between the Area (in %) in Seychelles in 2007 and the Area (in %) in Virgin Islands in 2008?
Your response must be concise. -0.68. What is the difference between the Area (in %) of St. Kitts and Nevis in 2007 and the Area (in %) of Virgin Islands in 2008?
Give a very brief answer. 12.49. What is the difference between the Area (in %) in Bermuda in 2007 and the Area (in %) in Seychelles in 2009?
Keep it short and to the point. 5.83. What is the difference between the Area (in %) in Bermuda in 2007 and the Area (in %) in St. Kitts and Nevis in 2009?
Offer a very short reply. -7.38. What is the difference between the Area (in %) in Bermuda in 2007 and the Area (in %) in Virgin Islands in 2009?
Make the answer very short. 5.14. What is the difference between the Area (in %) in Seychelles in 2007 and the Area (in %) in St. Kitts and Nevis in 2009?
Ensure brevity in your answer.  -13.21. What is the difference between the Area (in %) in Seychelles in 2007 and the Area (in %) in Virgin Islands in 2009?
Ensure brevity in your answer.  -0.68. What is the difference between the Area (in %) in St. Kitts and Nevis in 2007 and the Area (in %) in Virgin Islands in 2009?
Your response must be concise. 12.49. What is the difference between the Area (in %) of Bermuda in 2008 and the Area (in %) of Seychelles in 2009?
Provide a short and direct response. 3.83. What is the difference between the Area (in %) of Bermuda in 2008 and the Area (in %) of St. Kitts and Nevis in 2009?
Offer a very short reply. -9.38. What is the difference between the Area (in %) of Bermuda in 2008 and the Area (in %) of Virgin Islands in 2009?
Give a very brief answer. 3.14. What is the difference between the Area (in %) of Seychelles in 2008 and the Area (in %) of St. Kitts and Nevis in 2009?
Ensure brevity in your answer.  -13.21. What is the difference between the Area (in %) of Seychelles in 2008 and the Area (in %) of Virgin Islands in 2009?
Make the answer very short. -0.68. What is the difference between the Area (in %) of St. Kitts and Nevis in 2008 and the Area (in %) of Virgin Islands in 2009?
Your response must be concise. 12.53. What is the average Area (in %) in Seychelles per year?
Make the answer very short. 2.17. What is the average Area (in %) in St. Kitts and Nevis per year?
Offer a very short reply. 19.68. What is the average Area (in %) in Virgin Islands per year?
Your response must be concise. 4.29. In the year 2002, what is the difference between the Area (in %) of Bermuda and Area (in %) of Seychelles?
Ensure brevity in your answer.  5.83. In the year 2002, what is the difference between the Area (in %) of Bermuda and Area (in %) of St. Kitts and Nevis?
Make the answer very short. -18.92. In the year 2002, what is the difference between the Area (in %) of Bermuda and Area (in %) of Virgin Islands?
Provide a short and direct response. 2.29. In the year 2002, what is the difference between the Area (in %) in Seychelles and Area (in %) in St. Kitts and Nevis?
Your answer should be compact. -24.75. In the year 2002, what is the difference between the Area (in %) in Seychelles and Area (in %) in Virgin Islands?
Give a very brief answer. -3.54. In the year 2002, what is the difference between the Area (in %) in St. Kitts and Nevis and Area (in %) in Virgin Islands?
Offer a terse response. 21.21. In the year 2003, what is the difference between the Area (in %) of Bermuda and Area (in %) of Seychelles?
Your response must be concise. 5.83. In the year 2003, what is the difference between the Area (in %) of Bermuda and Area (in %) of St. Kitts and Nevis?
Give a very brief answer. -18.92. In the year 2003, what is the difference between the Area (in %) in Bermuda and Area (in %) in Virgin Islands?
Provide a short and direct response. 2.29. In the year 2003, what is the difference between the Area (in %) of Seychelles and Area (in %) of St. Kitts and Nevis?
Provide a short and direct response. -24.75. In the year 2003, what is the difference between the Area (in %) in Seychelles and Area (in %) in Virgin Islands?
Provide a short and direct response. -3.54. In the year 2003, what is the difference between the Area (in %) in St. Kitts and Nevis and Area (in %) in Virgin Islands?
Provide a short and direct response. 21.21. In the year 2004, what is the difference between the Area (in %) in Bermuda and Area (in %) in Seychelles?
Make the answer very short. 5.83. In the year 2004, what is the difference between the Area (in %) of Bermuda and Area (in %) of St. Kitts and Nevis?
Provide a short and direct response. -18.92. In the year 2004, what is the difference between the Area (in %) in Bermuda and Area (in %) in Virgin Islands?
Ensure brevity in your answer.  2.29. In the year 2004, what is the difference between the Area (in %) in Seychelles and Area (in %) in St. Kitts and Nevis?
Ensure brevity in your answer.  -24.75. In the year 2004, what is the difference between the Area (in %) of Seychelles and Area (in %) of Virgin Islands?
Provide a short and direct response. -3.54. In the year 2004, what is the difference between the Area (in %) in St. Kitts and Nevis and Area (in %) in Virgin Islands?
Give a very brief answer. 21.21. In the year 2005, what is the difference between the Area (in %) of Bermuda and Area (in %) of Seychelles?
Provide a short and direct response. 5.83. In the year 2005, what is the difference between the Area (in %) of Bermuda and Area (in %) of St. Kitts and Nevis?
Provide a succinct answer. -7.27. In the year 2005, what is the difference between the Area (in %) of Bermuda and Area (in %) of Virgin Islands?
Make the answer very short. 2.29. In the year 2005, what is the difference between the Area (in %) of Seychelles and Area (in %) of St. Kitts and Nevis?
Your answer should be compact. -13.1. In the year 2005, what is the difference between the Area (in %) in Seychelles and Area (in %) in Virgin Islands?
Offer a terse response. -3.54. In the year 2005, what is the difference between the Area (in %) in St. Kitts and Nevis and Area (in %) in Virgin Islands?
Your response must be concise. 9.55. In the year 2006, what is the difference between the Area (in %) in Bermuda and Area (in %) in Seychelles?
Ensure brevity in your answer.  5.83. In the year 2006, what is the difference between the Area (in %) in Bermuda and Area (in %) in St. Kitts and Nevis?
Your answer should be compact. -7.31. In the year 2006, what is the difference between the Area (in %) of Bermuda and Area (in %) of Virgin Islands?
Give a very brief answer. 5.14. In the year 2006, what is the difference between the Area (in %) in Seychelles and Area (in %) in St. Kitts and Nevis?
Provide a succinct answer. -13.13. In the year 2006, what is the difference between the Area (in %) in Seychelles and Area (in %) in Virgin Islands?
Ensure brevity in your answer.  -0.68. In the year 2006, what is the difference between the Area (in %) in St. Kitts and Nevis and Area (in %) in Virgin Islands?
Your response must be concise. 12.45. In the year 2007, what is the difference between the Area (in %) of Bermuda and Area (in %) of Seychelles?
Offer a terse response. 5.83. In the year 2007, what is the difference between the Area (in %) in Bermuda and Area (in %) in St. Kitts and Nevis?
Offer a terse response. -7.35. In the year 2007, what is the difference between the Area (in %) in Bermuda and Area (in %) in Virgin Islands?
Keep it short and to the point. 5.14. In the year 2007, what is the difference between the Area (in %) in Seychelles and Area (in %) in St. Kitts and Nevis?
Offer a very short reply. -13.17. In the year 2007, what is the difference between the Area (in %) in Seychelles and Area (in %) in Virgin Islands?
Offer a very short reply. -0.68. In the year 2007, what is the difference between the Area (in %) in St. Kitts and Nevis and Area (in %) in Virgin Islands?
Your answer should be very brief. 12.49. In the year 2008, what is the difference between the Area (in %) in Bermuda and Area (in %) in Seychelles?
Offer a very short reply. 3.83. In the year 2008, what is the difference between the Area (in %) in Bermuda and Area (in %) in St. Kitts and Nevis?
Your answer should be compact. -9.38. In the year 2008, what is the difference between the Area (in %) in Bermuda and Area (in %) in Virgin Islands?
Your answer should be very brief. 3.14. In the year 2008, what is the difference between the Area (in %) of Seychelles and Area (in %) of St. Kitts and Nevis?
Your answer should be compact. -13.21. In the year 2008, what is the difference between the Area (in %) in Seychelles and Area (in %) in Virgin Islands?
Make the answer very short. -0.68. In the year 2008, what is the difference between the Area (in %) in St. Kitts and Nevis and Area (in %) in Virgin Islands?
Offer a very short reply. 12.53. In the year 2009, what is the difference between the Area (in %) of Bermuda and Area (in %) of Seychelles?
Your answer should be compact. 3.83. In the year 2009, what is the difference between the Area (in %) in Bermuda and Area (in %) in St. Kitts and Nevis?
Make the answer very short. -9.38. In the year 2009, what is the difference between the Area (in %) in Bermuda and Area (in %) in Virgin Islands?
Give a very brief answer. 3.14. In the year 2009, what is the difference between the Area (in %) of Seychelles and Area (in %) of St. Kitts and Nevis?
Offer a terse response. -13.21. In the year 2009, what is the difference between the Area (in %) of Seychelles and Area (in %) of Virgin Islands?
Offer a terse response. -0.68. In the year 2009, what is the difference between the Area (in %) of St. Kitts and Nevis and Area (in %) of Virgin Islands?
Provide a succinct answer. 12.53. What is the ratio of the Area (in %) of St. Kitts and Nevis in 2002 to that in 2003?
Make the answer very short. 1. What is the ratio of the Area (in %) of Virgin Islands in 2002 to that in 2003?
Offer a very short reply. 1. What is the ratio of the Area (in %) in St. Kitts and Nevis in 2002 to that in 2004?
Your answer should be very brief. 1. What is the ratio of the Area (in %) of Virgin Islands in 2002 to that in 2004?
Offer a very short reply. 1. What is the ratio of the Area (in %) in Seychelles in 2002 to that in 2005?
Your answer should be very brief. 1. What is the ratio of the Area (in %) in St. Kitts and Nevis in 2002 to that in 2005?
Provide a short and direct response. 1.76. What is the ratio of the Area (in %) in Virgin Islands in 2002 to that in 2005?
Give a very brief answer. 1. What is the ratio of the Area (in %) of Bermuda in 2002 to that in 2006?
Offer a very short reply. 1. What is the ratio of the Area (in %) of St. Kitts and Nevis in 2002 to that in 2006?
Offer a terse response. 1.76. What is the ratio of the Area (in %) of Bermuda in 2002 to that in 2007?
Provide a succinct answer. 1. What is the ratio of the Area (in %) in Seychelles in 2002 to that in 2007?
Provide a succinct answer. 1. What is the ratio of the Area (in %) in St. Kitts and Nevis in 2002 to that in 2007?
Offer a terse response. 1.75. What is the ratio of the Area (in %) of St. Kitts and Nevis in 2002 to that in 2008?
Offer a very short reply. 1.75. What is the ratio of the Area (in %) of Bermuda in 2002 to that in 2009?
Ensure brevity in your answer.  1.33. What is the ratio of the Area (in %) of Seychelles in 2002 to that in 2009?
Give a very brief answer. 1. What is the ratio of the Area (in %) in Virgin Islands in 2002 to that in 2009?
Offer a very short reply. 2. What is the ratio of the Area (in %) of St. Kitts and Nevis in 2003 to that in 2004?
Your response must be concise. 1. What is the ratio of the Area (in %) in Virgin Islands in 2003 to that in 2004?
Offer a terse response. 1. What is the ratio of the Area (in %) in Seychelles in 2003 to that in 2005?
Your answer should be compact. 1. What is the ratio of the Area (in %) of St. Kitts and Nevis in 2003 to that in 2005?
Your response must be concise. 1.76. What is the ratio of the Area (in %) in Virgin Islands in 2003 to that in 2005?
Your answer should be compact. 1. What is the ratio of the Area (in %) in Bermuda in 2003 to that in 2006?
Keep it short and to the point. 1. What is the ratio of the Area (in %) in Seychelles in 2003 to that in 2006?
Give a very brief answer. 1. What is the ratio of the Area (in %) of St. Kitts and Nevis in 2003 to that in 2006?
Offer a terse response. 1.76. What is the ratio of the Area (in %) in Bermuda in 2003 to that in 2007?
Provide a succinct answer. 1. What is the ratio of the Area (in %) of Seychelles in 2003 to that in 2007?
Your response must be concise. 1. What is the ratio of the Area (in %) of St. Kitts and Nevis in 2003 to that in 2007?
Provide a short and direct response. 1.75. What is the ratio of the Area (in %) in Virgin Islands in 2003 to that in 2007?
Provide a succinct answer. 2. What is the ratio of the Area (in %) in Virgin Islands in 2003 to that in 2008?
Offer a very short reply. 2. What is the ratio of the Area (in %) of Bermuda in 2003 to that in 2009?
Your answer should be very brief. 1.33. What is the ratio of the Area (in %) of Seychelles in 2003 to that in 2009?
Keep it short and to the point. 1. What is the ratio of the Area (in %) in Virgin Islands in 2003 to that in 2009?
Offer a very short reply. 2. What is the ratio of the Area (in %) in St. Kitts and Nevis in 2004 to that in 2005?
Provide a succinct answer. 1.76. What is the ratio of the Area (in %) in Bermuda in 2004 to that in 2006?
Offer a terse response. 1. What is the ratio of the Area (in %) of Seychelles in 2004 to that in 2006?
Make the answer very short. 1. What is the ratio of the Area (in %) of St. Kitts and Nevis in 2004 to that in 2006?
Provide a short and direct response. 1.76. What is the ratio of the Area (in %) of Virgin Islands in 2004 to that in 2006?
Offer a very short reply. 2. What is the ratio of the Area (in %) in Bermuda in 2004 to that in 2007?
Your answer should be very brief. 1. What is the ratio of the Area (in %) of Seychelles in 2004 to that in 2007?
Provide a succinct answer. 1. What is the ratio of the Area (in %) of St. Kitts and Nevis in 2004 to that in 2007?
Your answer should be very brief. 1.75. What is the ratio of the Area (in %) in Bermuda in 2004 to that in 2008?
Offer a terse response. 1.33. What is the ratio of the Area (in %) in St. Kitts and Nevis in 2004 to that in 2008?
Offer a terse response. 1.75. What is the ratio of the Area (in %) of Virgin Islands in 2004 to that in 2008?
Your response must be concise. 2. What is the ratio of the Area (in %) of Bermuda in 2004 to that in 2009?
Your response must be concise. 1.33. What is the ratio of the Area (in %) in Seychelles in 2004 to that in 2009?
Provide a short and direct response. 1. What is the ratio of the Area (in %) in St. Kitts and Nevis in 2004 to that in 2009?
Offer a very short reply. 1.75. What is the ratio of the Area (in %) in Bermuda in 2005 to that in 2006?
Offer a very short reply. 1. What is the ratio of the Area (in %) of St. Kitts and Nevis in 2005 to that in 2006?
Ensure brevity in your answer.  1. What is the ratio of the Area (in %) of Bermuda in 2005 to that in 2007?
Give a very brief answer. 1. What is the ratio of the Area (in %) in Bermuda in 2005 to that in 2008?
Your response must be concise. 1.33. What is the ratio of the Area (in %) of Seychelles in 2005 to that in 2008?
Ensure brevity in your answer.  1. What is the ratio of the Area (in %) in Bermuda in 2005 to that in 2009?
Your answer should be compact. 1.33. What is the ratio of the Area (in %) in Seychelles in 2005 to that in 2009?
Offer a terse response. 1. What is the ratio of the Area (in %) in Virgin Islands in 2005 to that in 2009?
Your answer should be very brief. 2. What is the ratio of the Area (in %) in St. Kitts and Nevis in 2006 to that in 2007?
Your answer should be very brief. 1. What is the ratio of the Area (in %) in Virgin Islands in 2006 to that in 2007?
Give a very brief answer. 1. What is the ratio of the Area (in %) in Bermuda in 2006 to that in 2008?
Your answer should be compact. 1.33. What is the ratio of the Area (in %) of Seychelles in 2006 to that in 2008?
Provide a succinct answer. 1. What is the ratio of the Area (in %) in Virgin Islands in 2006 to that in 2008?
Offer a terse response. 1. What is the ratio of the Area (in %) of Bermuda in 2007 to that in 2009?
Provide a succinct answer. 1.33. What is the ratio of the Area (in %) of St. Kitts and Nevis in 2007 to that in 2009?
Ensure brevity in your answer.  1. What is the ratio of the Area (in %) of Virgin Islands in 2007 to that in 2009?
Your answer should be very brief. 1. What is the ratio of the Area (in %) of Seychelles in 2008 to that in 2009?
Give a very brief answer. 1. What is the ratio of the Area (in %) of St. Kitts and Nevis in 2008 to that in 2009?
Provide a short and direct response. 1. What is the difference between the highest and the second highest Area (in %) of Bermuda?
Your response must be concise. 0. What is the difference between the highest and the second highest Area (in %) in Seychelles?
Give a very brief answer. 0. What is the difference between the highest and the second highest Area (in %) in St. Kitts and Nevis?
Give a very brief answer. 0. What is the difference between the highest and the lowest Area (in %) in Bermuda?
Ensure brevity in your answer.  2. What is the difference between the highest and the lowest Area (in %) of St. Kitts and Nevis?
Provide a succinct answer. 11.65. What is the difference between the highest and the lowest Area (in %) in Virgin Islands?
Offer a terse response. 2.86. 